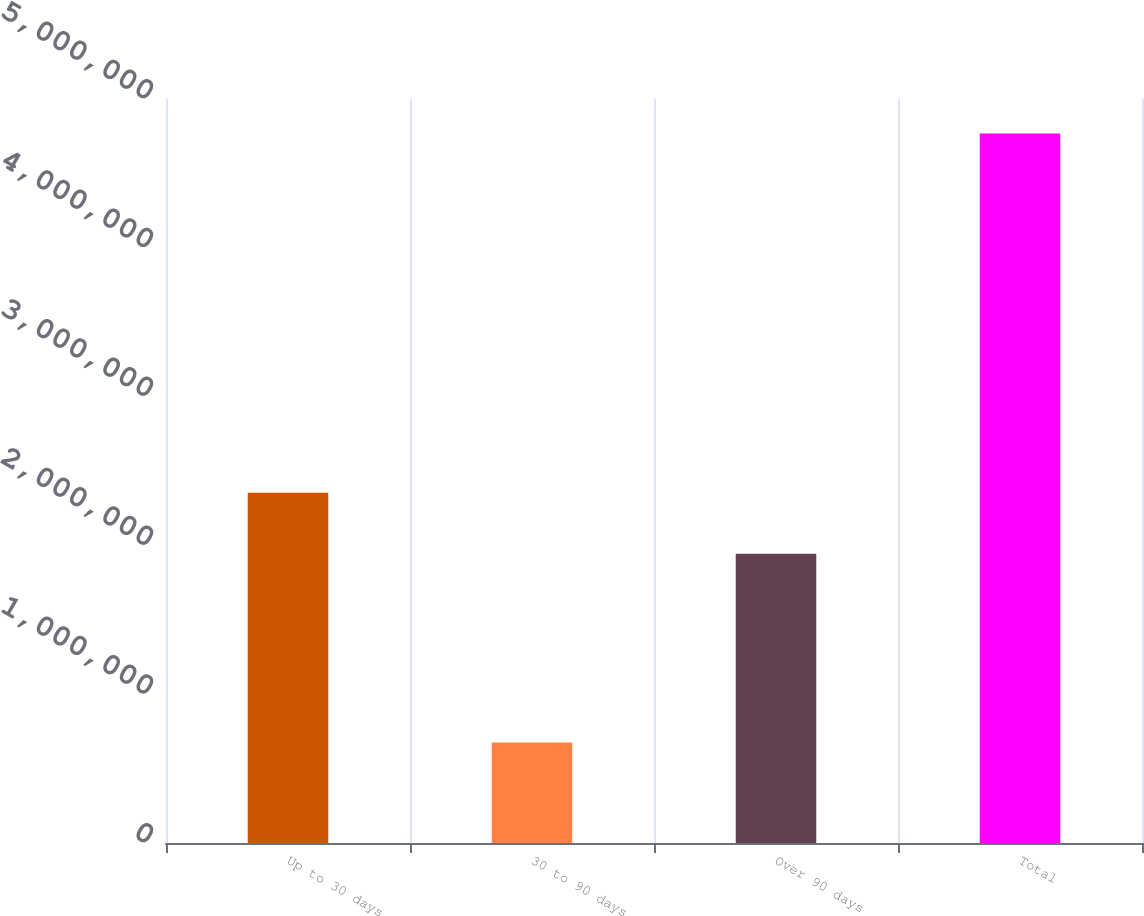Convert chart to OTSL. <chart><loc_0><loc_0><loc_500><loc_500><bar_chart><fcel>Up to 30 days<fcel>30 to 90 days<fcel>Over 90 days<fcel>Total<nl><fcel>2.3534e+06<fcel>676224<fcel>1.94414e+06<fcel>4.76882e+06<nl></chart> 